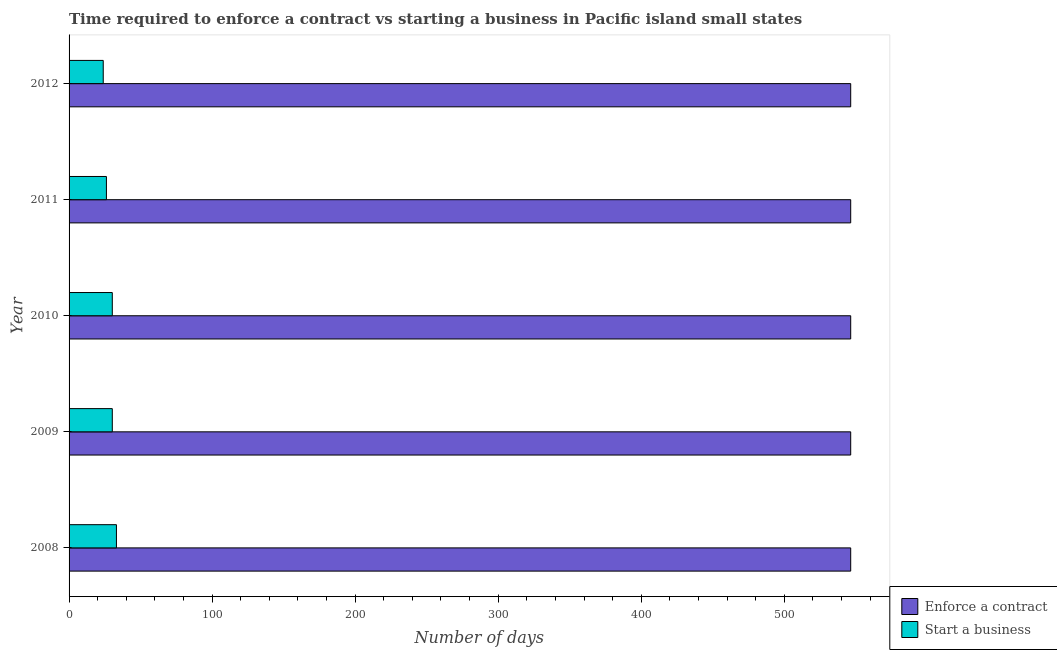How many different coloured bars are there?
Your answer should be very brief. 2. How many bars are there on the 2nd tick from the top?
Provide a succinct answer. 2. What is the number of days to start a business in 2010?
Your answer should be compact. 30.22. Across all years, what is the maximum number of days to enforece a contract?
Offer a very short reply. 546.44. Across all years, what is the minimum number of days to enforece a contract?
Your response must be concise. 546.44. What is the total number of days to enforece a contract in the graph?
Offer a terse response. 2732.22. What is the difference between the number of days to start a business in 2010 and the number of days to enforece a contract in 2009?
Provide a short and direct response. -516.22. What is the average number of days to enforece a contract per year?
Offer a very short reply. 546.44. In the year 2008, what is the difference between the number of days to enforece a contract and number of days to start a business?
Provide a succinct answer. 513.33. In how many years, is the number of days to enforece a contract greater than 180 days?
Offer a terse response. 5. What is the ratio of the number of days to start a business in 2008 to that in 2011?
Provide a succinct answer. 1.27. What is the difference between the highest and the second highest number of days to enforece a contract?
Provide a succinct answer. 0. What does the 2nd bar from the top in 2012 represents?
Your response must be concise. Enforce a contract. What does the 2nd bar from the bottom in 2012 represents?
Give a very brief answer. Start a business. How many years are there in the graph?
Keep it short and to the point. 5. What is the difference between two consecutive major ticks on the X-axis?
Your answer should be very brief. 100. Does the graph contain grids?
Your answer should be very brief. No. How many legend labels are there?
Provide a short and direct response. 2. How are the legend labels stacked?
Give a very brief answer. Vertical. What is the title of the graph?
Offer a very short reply. Time required to enforce a contract vs starting a business in Pacific island small states. Does "Current US$" appear as one of the legend labels in the graph?
Make the answer very short. No. What is the label or title of the X-axis?
Give a very brief answer. Number of days. What is the label or title of the Y-axis?
Give a very brief answer. Year. What is the Number of days in Enforce a contract in 2008?
Offer a terse response. 546.44. What is the Number of days in Start a business in 2008?
Keep it short and to the point. 33.11. What is the Number of days in Enforce a contract in 2009?
Give a very brief answer. 546.44. What is the Number of days in Start a business in 2009?
Your answer should be compact. 30.22. What is the Number of days of Enforce a contract in 2010?
Provide a short and direct response. 546.44. What is the Number of days of Start a business in 2010?
Keep it short and to the point. 30.22. What is the Number of days in Enforce a contract in 2011?
Your answer should be very brief. 546.44. What is the Number of days in Start a business in 2011?
Provide a succinct answer. 26.11. What is the Number of days of Enforce a contract in 2012?
Provide a succinct answer. 546.44. What is the Number of days of Start a business in 2012?
Your answer should be compact. 23.89. Across all years, what is the maximum Number of days in Enforce a contract?
Your answer should be very brief. 546.44. Across all years, what is the maximum Number of days in Start a business?
Make the answer very short. 33.11. Across all years, what is the minimum Number of days of Enforce a contract?
Your answer should be compact. 546.44. Across all years, what is the minimum Number of days of Start a business?
Ensure brevity in your answer.  23.89. What is the total Number of days of Enforce a contract in the graph?
Offer a terse response. 2732.22. What is the total Number of days in Start a business in the graph?
Offer a terse response. 143.56. What is the difference between the Number of days of Enforce a contract in 2008 and that in 2009?
Keep it short and to the point. 0. What is the difference between the Number of days in Start a business in 2008 and that in 2009?
Make the answer very short. 2.89. What is the difference between the Number of days of Start a business in 2008 and that in 2010?
Provide a short and direct response. 2.89. What is the difference between the Number of days in Enforce a contract in 2008 and that in 2011?
Offer a very short reply. 0. What is the difference between the Number of days in Start a business in 2008 and that in 2011?
Give a very brief answer. 7. What is the difference between the Number of days in Enforce a contract in 2008 and that in 2012?
Your response must be concise. 0. What is the difference between the Number of days in Start a business in 2008 and that in 2012?
Your answer should be compact. 9.22. What is the difference between the Number of days in Start a business in 2009 and that in 2010?
Offer a very short reply. 0. What is the difference between the Number of days in Start a business in 2009 and that in 2011?
Ensure brevity in your answer.  4.11. What is the difference between the Number of days of Start a business in 2009 and that in 2012?
Provide a short and direct response. 6.33. What is the difference between the Number of days in Enforce a contract in 2010 and that in 2011?
Give a very brief answer. 0. What is the difference between the Number of days in Start a business in 2010 and that in 2011?
Offer a terse response. 4.11. What is the difference between the Number of days of Start a business in 2010 and that in 2012?
Offer a terse response. 6.33. What is the difference between the Number of days of Enforce a contract in 2011 and that in 2012?
Your answer should be compact. 0. What is the difference between the Number of days in Start a business in 2011 and that in 2012?
Offer a terse response. 2.22. What is the difference between the Number of days of Enforce a contract in 2008 and the Number of days of Start a business in 2009?
Your response must be concise. 516.22. What is the difference between the Number of days in Enforce a contract in 2008 and the Number of days in Start a business in 2010?
Your answer should be very brief. 516.22. What is the difference between the Number of days in Enforce a contract in 2008 and the Number of days in Start a business in 2011?
Your answer should be very brief. 520.33. What is the difference between the Number of days of Enforce a contract in 2008 and the Number of days of Start a business in 2012?
Ensure brevity in your answer.  522.56. What is the difference between the Number of days of Enforce a contract in 2009 and the Number of days of Start a business in 2010?
Offer a very short reply. 516.22. What is the difference between the Number of days of Enforce a contract in 2009 and the Number of days of Start a business in 2011?
Ensure brevity in your answer.  520.33. What is the difference between the Number of days of Enforce a contract in 2009 and the Number of days of Start a business in 2012?
Give a very brief answer. 522.56. What is the difference between the Number of days in Enforce a contract in 2010 and the Number of days in Start a business in 2011?
Offer a very short reply. 520.33. What is the difference between the Number of days in Enforce a contract in 2010 and the Number of days in Start a business in 2012?
Your response must be concise. 522.56. What is the difference between the Number of days of Enforce a contract in 2011 and the Number of days of Start a business in 2012?
Provide a short and direct response. 522.56. What is the average Number of days of Enforce a contract per year?
Your answer should be compact. 546.44. What is the average Number of days of Start a business per year?
Provide a short and direct response. 28.71. In the year 2008, what is the difference between the Number of days of Enforce a contract and Number of days of Start a business?
Keep it short and to the point. 513.33. In the year 2009, what is the difference between the Number of days of Enforce a contract and Number of days of Start a business?
Give a very brief answer. 516.22. In the year 2010, what is the difference between the Number of days in Enforce a contract and Number of days in Start a business?
Make the answer very short. 516.22. In the year 2011, what is the difference between the Number of days of Enforce a contract and Number of days of Start a business?
Give a very brief answer. 520.33. In the year 2012, what is the difference between the Number of days in Enforce a contract and Number of days in Start a business?
Your answer should be compact. 522.56. What is the ratio of the Number of days of Start a business in 2008 to that in 2009?
Your answer should be compact. 1.1. What is the ratio of the Number of days of Enforce a contract in 2008 to that in 2010?
Provide a succinct answer. 1. What is the ratio of the Number of days in Start a business in 2008 to that in 2010?
Provide a succinct answer. 1.1. What is the ratio of the Number of days of Start a business in 2008 to that in 2011?
Provide a short and direct response. 1.27. What is the ratio of the Number of days of Enforce a contract in 2008 to that in 2012?
Offer a terse response. 1. What is the ratio of the Number of days in Start a business in 2008 to that in 2012?
Provide a succinct answer. 1.39. What is the ratio of the Number of days of Start a business in 2009 to that in 2010?
Ensure brevity in your answer.  1. What is the ratio of the Number of days in Start a business in 2009 to that in 2011?
Provide a succinct answer. 1.16. What is the ratio of the Number of days in Enforce a contract in 2009 to that in 2012?
Your response must be concise. 1. What is the ratio of the Number of days of Start a business in 2009 to that in 2012?
Provide a succinct answer. 1.27. What is the ratio of the Number of days in Enforce a contract in 2010 to that in 2011?
Your response must be concise. 1. What is the ratio of the Number of days of Start a business in 2010 to that in 2011?
Offer a very short reply. 1.16. What is the ratio of the Number of days of Start a business in 2010 to that in 2012?
Give a very brief answer. 1.27. What is the ratio of the Number of days in Enforce a contract in 2011 to that in 2012?
Ensure brevity in your answer.  1. What is the ratio of the Number of days in Start a business in 2011 to that in 2012?
Make the answer very short. 1.09. What is the difference between the highest and the second highest Number of days in Enforce a contract?
Give a very brief answer. 0. What is the difference between the highest and the second highest Number of days of Start a business?
Your answer should be compact. 2.89. What is the difference between the highest and the lowest Number of days of Enforce a contract?
Keep it short and to the point. 0. What is the difference between the highest and the lowest Number of days in Start a business?
Your answer should be compact. 9.22. 